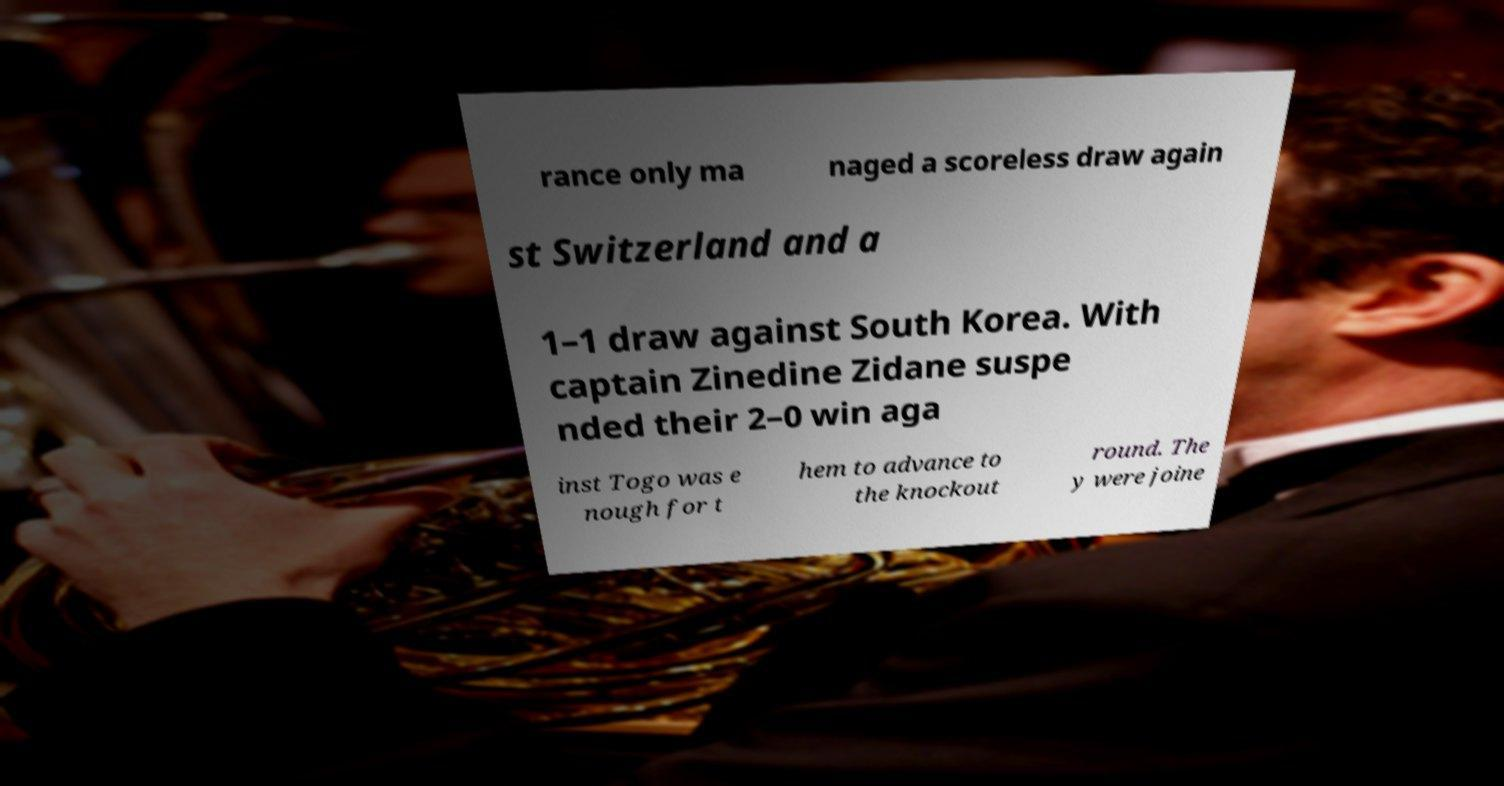Can you accurately transcribe the text from the provided image for me? rance only ma naged a scoreless draw again st Switzerland and a 1–1 draw against South Korea. With captain Zinedine Zidane suspe nded their 2–0 win aga inst Togo was e nough for t hem to advance to the knockout round. The y were joine 